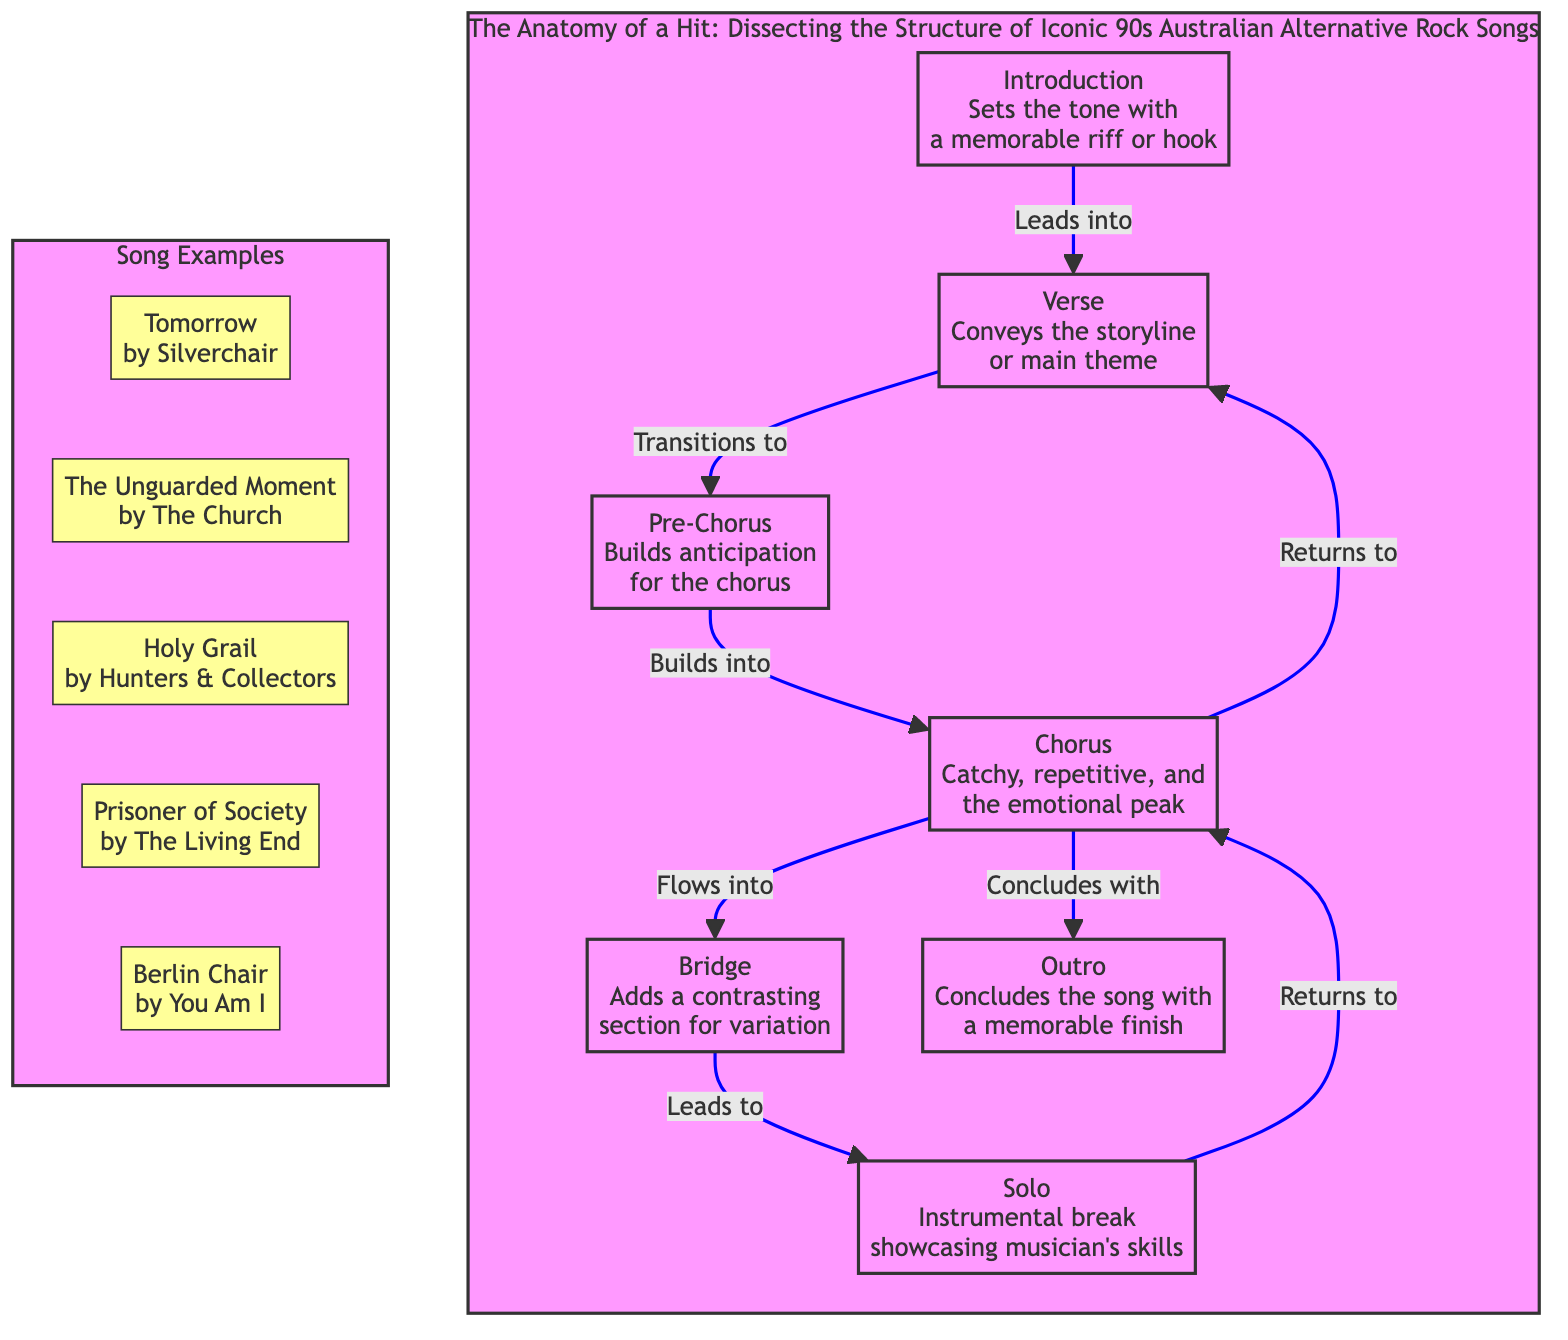What is the first section of the song structure? The diagram indicates that the first section of the song structure is the "Introduction," which sets the tone with a memorable riff or hook.
Answer: Introduction How many sections are there in the song structure? By counting the nodes in the diagram, we see there are a total of seven sections: Introduction, Verse, Pre-Chorus, Chorus, Bridge, Solo, and Outro.
Answer: 7 Which section comes after the Pre-Chorus? Following the flow of the diagram, after the Pre-Chorus, the next section is the Chorus, which is mentioned as the emotional peak.
Answer: Chorus What section introduces a contrasting variation? According to the diagram, the section that adds a contrasting section for variation is the "Bridge." This section typically diversifies the overall song structure.
Answer: Bridge Which song example is associated with Silverchair? Referring to the song examples provided in the diagram, the song associated with Silverchair is "Tomorrow."
Answer: Tomorrow What section concludes the song? The diagram specifies that the "Outro" is the section that concludes the song, providing a memorable finish.
Answer: Outro Which two sections does the Chorus flow into? Analyzing the diagram, the Chorus flows into the Bridge and also returns to the Verse, as indicated by the arrows leading from the Chorus.
Answer: Bridge, Verse What is the role of the Solo in the structure? The Solo serves as an instrumental break that showcases the musician's skills, adding a distinctive highlight to the song.
Answer: Instrumental break Which song example is by The Church? Based on the song examples in the diagram, "The Unguarded Moment" is the song associated with The Church.
Answer: The Unguarded Moment 